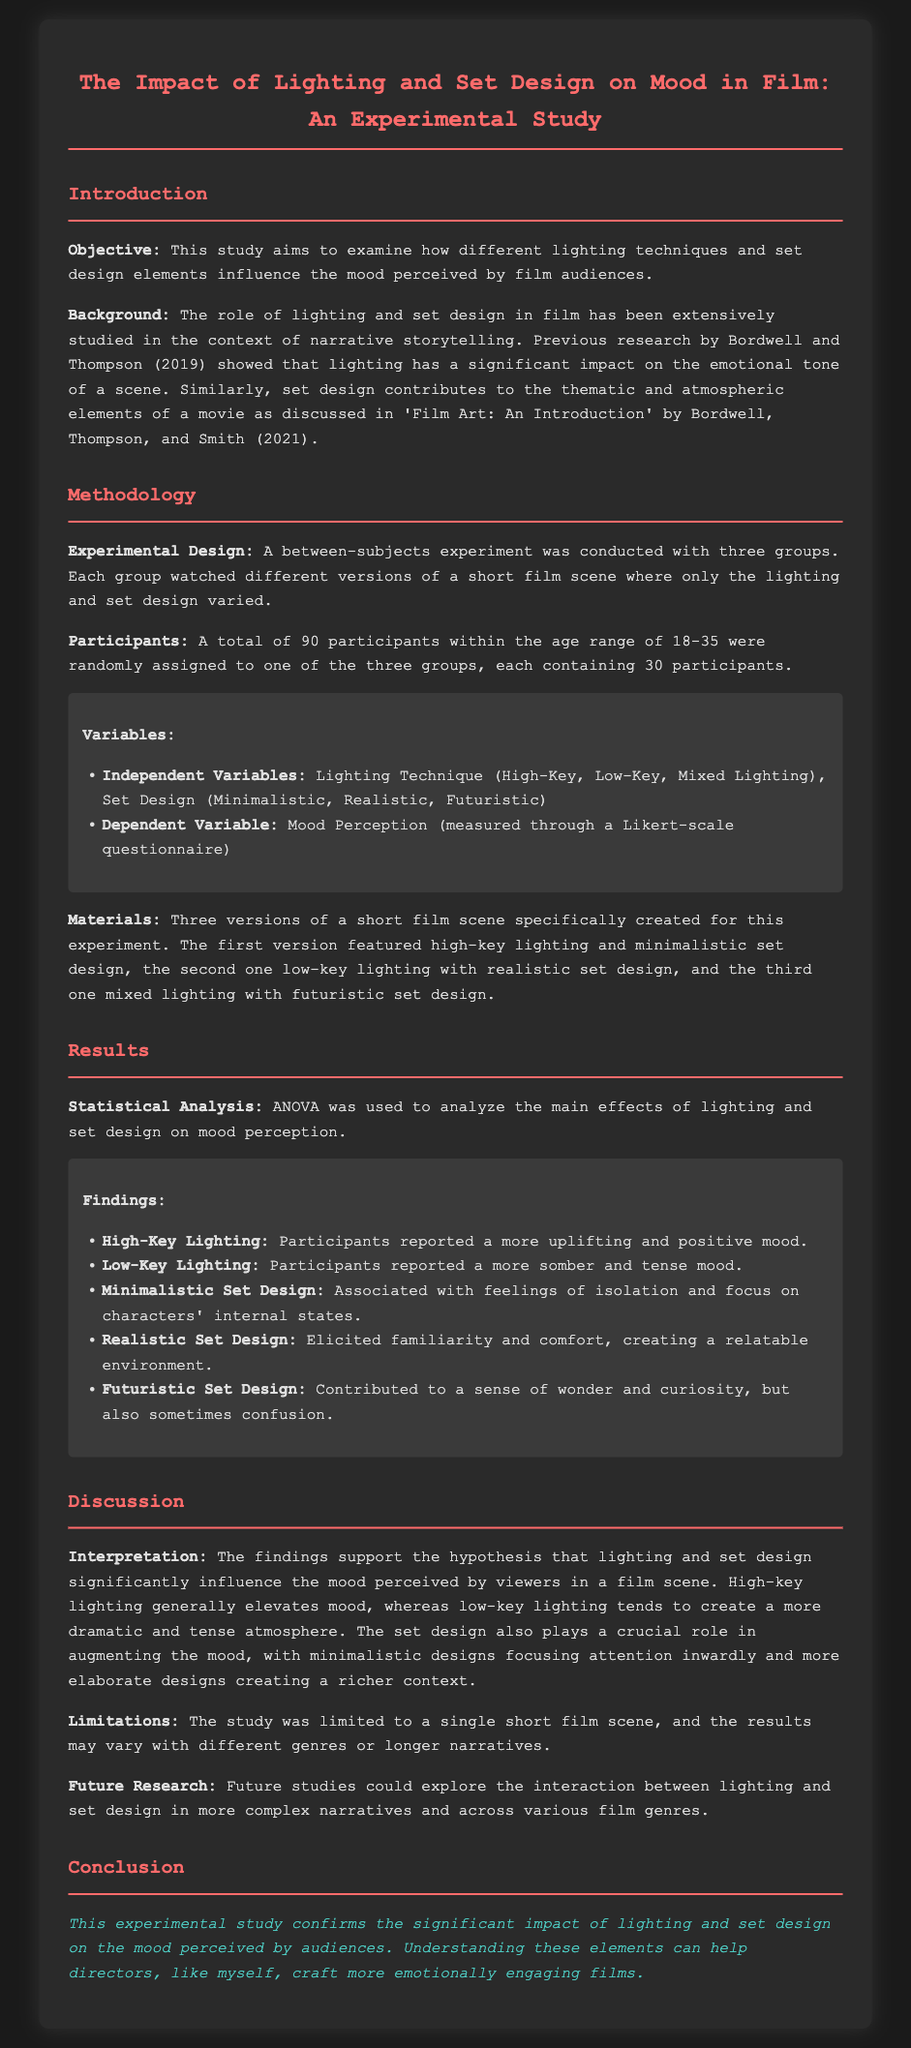What is the objective of the study? The objective is to examine how different lighting techniques and set design elements influence the mood perceived by film audiences.
Answer: To examine how different lighting techniques and set design elements influence the mood perceived by film audiences How many participants were involved in the study? The total number of participants is specified in the methodology section of the document as 90.
Answer: 90 What lighting technique was associated with a more somber mood? The results section specifies that low-key lighting was associated with a more somber and tense mood.
Answer: Low-Key Lighting What is one limitation mentioned in the study? The limitations are discussed in the document, specifically that the study was limited to a single short film scene.
Answer: Limited to a single short film scene Which set design elicited feelings of isolation? The findings indicate that minimalistic set design was associated with feelings of isolation and focus on characters' internal states.
Answer: Minimalistic Set Design What statistical analysis method was used in this study? The document states that ANOVA was used to analyze the main effects of lighting and set design on mood perception.
Answer: ANOVA What future research is suggested in the document? The document mentions exploring the interaction between lighting and set design in more complex narratives and across various film genres.
Answer: Interaction between lighting and set design in more complex narratives What color was used for the titles in the document? The titles are specifically highlighted in the document as being colored in a particular shade, which is pink.
Answer: Pink 